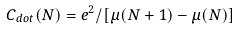<formula> <loc_0><loc_0><loc_500><loc_500>C _ { d o t } ( N ) = e ^ { 2 } / [ \mu ( N + 1 ) - \mu ( N ) ]</formula> 